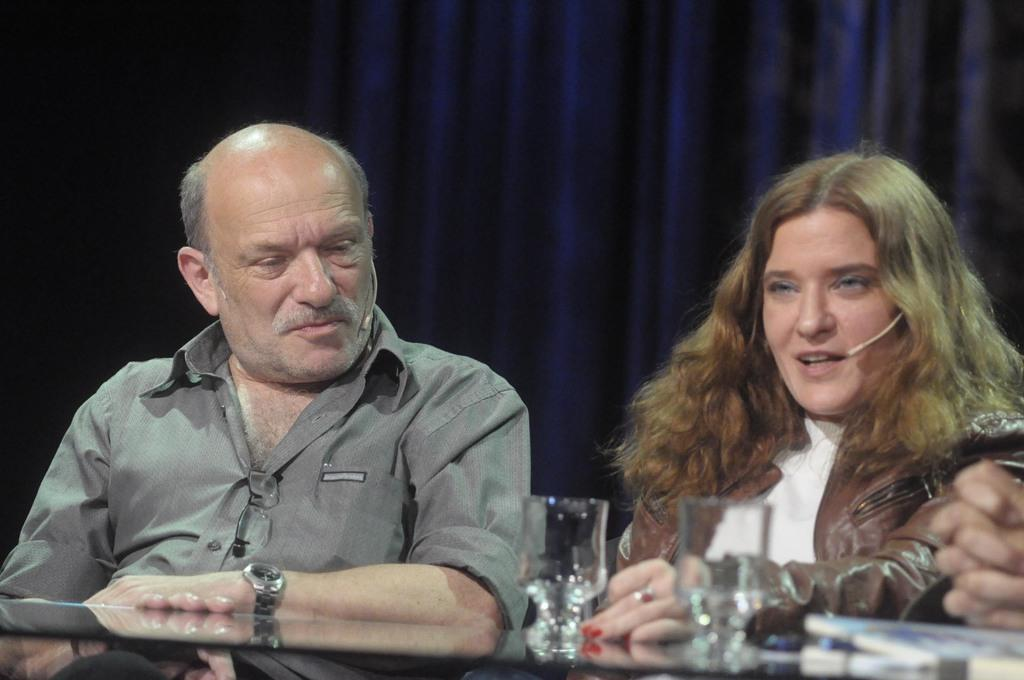Who is present in the image? There is a man and a woman in the image. What are the man and woman doing in the image? The man and woman are sitting at a table. What objects can be seen on the table? There are glass tumblers on the table. What can be seen in the background of the image? There is a curtain in the background of the image. Can you hear the robin laughing in the image? There is no robin or laughter present in the image. How many family members are visible in the image? The image only shows a man and a woman, so it is not possible to determine the number of family members. 